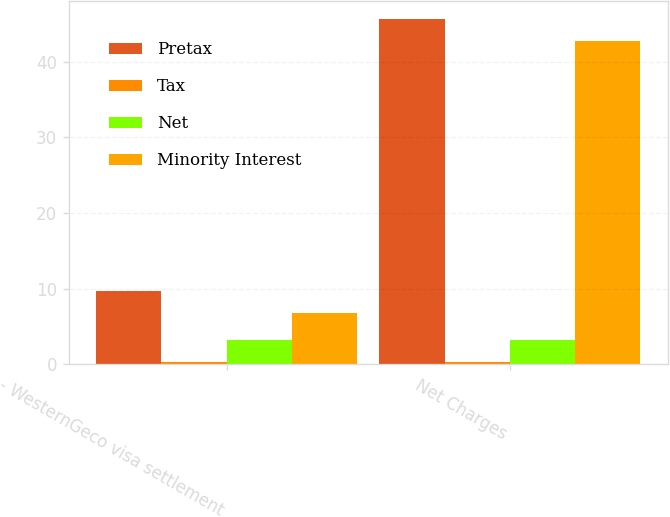<chart> <loc_0><loc_0><loc_500><loc_500><stacked_bar_chart><ecel><fcel>- WesternGeco visa settlement<fcel>Net Charges<nl><fcel>Pretax<fcel>9.7<fcel>45.7<nl><fcel>Tax<fcel>0.3<fcel>0.3<nl><fcel>Net<fcel>3.2<fcel>3.2<nl><fcel>Minority Interest<fcel>6.8<fcel>42.8<nl></chart> 